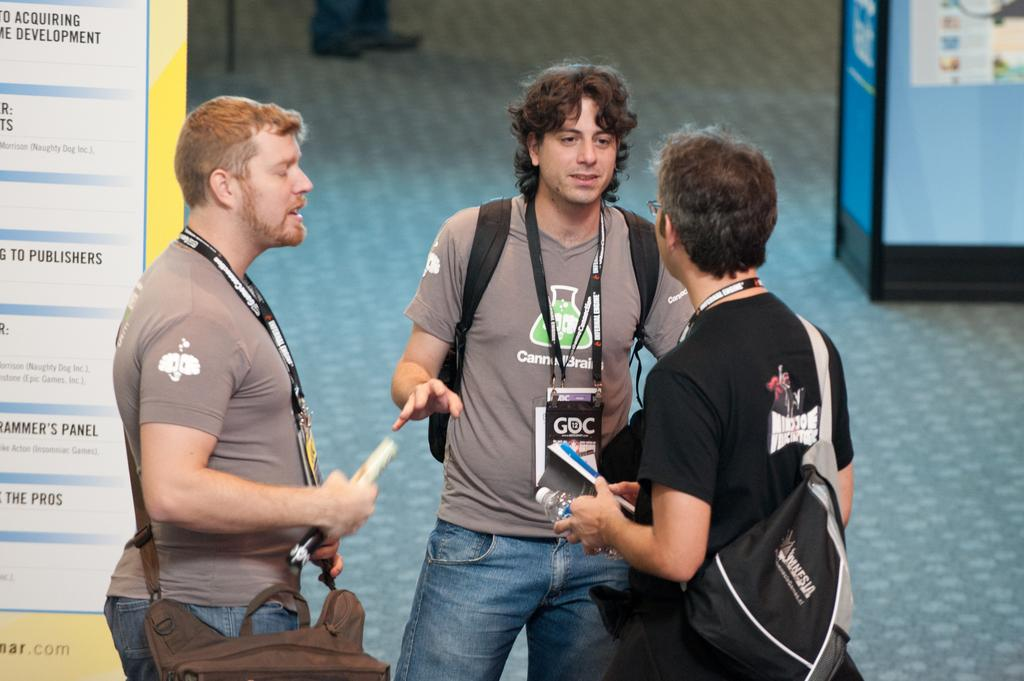How many men are in the image? There are three men in the image. What are the men doing in the image? The men are standing and carrying bags. What is the surface on which the men are standing? There is a floor visible in the image. What objects can be seen in the image besides the men? There is a board and a box in the image. What can be seen in the background of the image? In the background of the image, there are person's legs visible. What type of grain is being judged by the silver panel in the image? There is no grain, judge, or silver panel present in the image. 